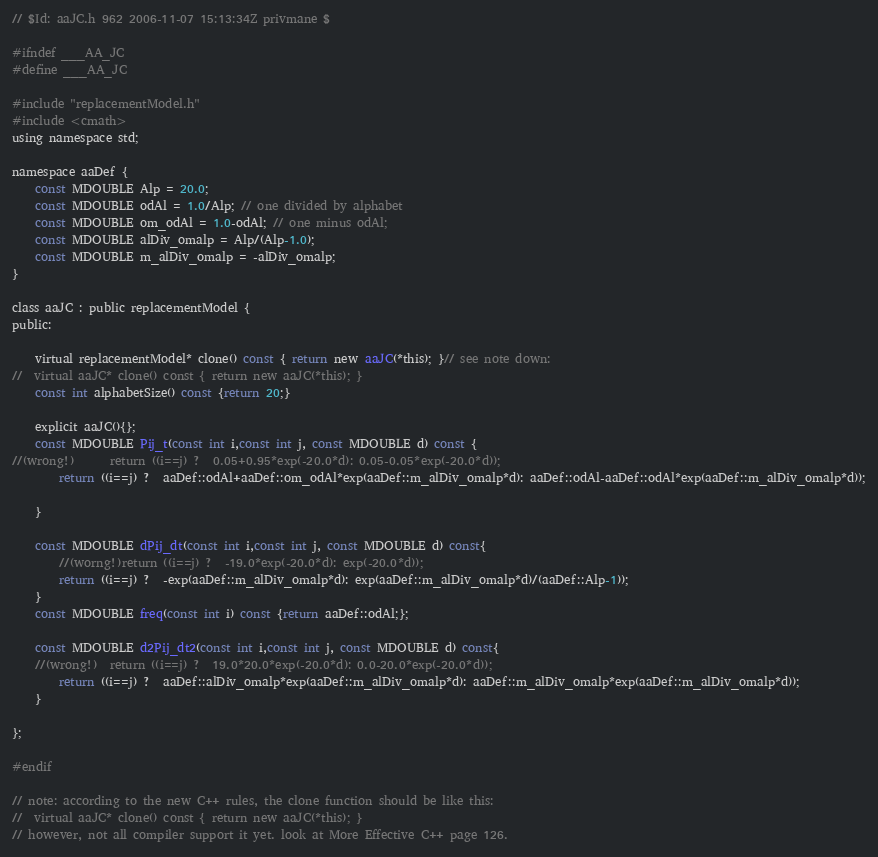<code> <loc_0><loc_0><loc_500><loc_500><_C_>// $Id: aaJC.h 962 2006-11-07 15:13:34Z privmane $

#ifndef ___AA_JC
#define ___AA_JC

#include "replacementModel.h"
#include <cmath>
using namespace std;

namespace aaDef {
	const MDOUBLE Alp = 20.0;
	const MDOUBLE odAl = 1.0/Alp; // one divided by alphabet
	const MDOUBLE om_odAl = 1.0-odAl; // one minus odAl;
	const MDOUBLE alDiv_omalp = Alp/(Alp-1.0);
	const MDOUBLE m_alDiv_omalp = -alDiv_omalp;
}

class aaJC : public replacementModel {
public:

	virtual replacementModel* clone() const { return new aaJC(*this); }// see note down:
//	virtual aaJC* clone() const { return new aaJC(*this); } 
	const int alphabetSize() const {return 20;}

	explicit aaJC(){};
	const MDOUBLE Pij_t(const int i,const int j, const MDOUBLE d) const {
//(wrong!)		return ((i==j) ?  0.05+0.95*exp(-20.0*d): 0.05-0.05*exp(-20.0*d));
		return ((i==j) ?  aaDef::odAl+aaDef::om_odAl*exp(aaDef::m_alDiv_omalp*d): aaDef::odAl-aaDef::odAl*exp(aaDef::m_alDiv_omalp*d));

	}

	const MDOUBLE dPij_dt(const int i,const int j, const MDOUBLE d) const{
		//(worng!)return ((i==j) ?  -19.0*exp(-20.0*d): exp(-20.0*d));
		return ((i==j) ?  -exp(aaDef::m_alDiv_omalp*d): exp(aaDef::m_alDiv_omalp*d)/(aaDef::Alp-1));
	}
	const MDOUBLE freq(const int i) const {return aaDef::odAl;};

	const MDOUBLE d2Pij_dt2(const int i,const int j, const MDOUBLE d) const{
	//(wrong!)	return ((i==j) ?  19.0*20.0*exp(-20.0*d): 0.0-20.0*exp(-20.0*d));
		return ((i==j) ?  aaDef::alDiv_omalp*exp(aaDef::m_alDiv_omalp*d): aaDef::m_alDiv_omalp*exp(aaDef::m_alDiv_omalp*d));
	}

};

#endif 

// note: according to the new C++ rules, the clone function should be like this:
//	virtual aaJC* clone() const { return new aaJC(*this); }
// however, not all compiler support it yet. look at More Effective C++ page 126.



</code> 